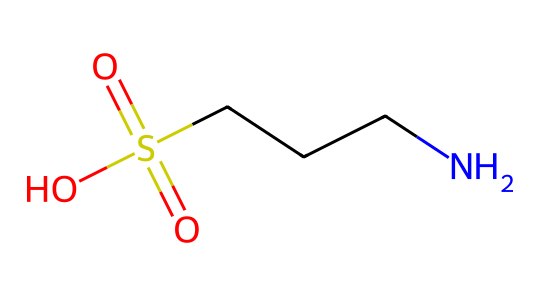What is the molecular formula of taurine? To determine the molecular formula from the SMILES representation, we identify the elements present (C for carbon, N for nitrogen, O for oxygen, and S for sulfur) and count their respective atoms. The SMILES indicates 2 carbon atoms, 1 nitrogen atom, 1 sulfur atom, and 4 oxygen atoms in total, leading to the molecular formula C2H7NO6S.
Answer: C2H7NO6S How many sulfur atoms are in taurine? By analyzing the SMILES representation, we see that there is one sulfur (S) atom represented in the structure, which can be directly counted.
Answer: 1 What functional groups are present in taurine? The SMILES representation shows a sulfonic acid group (indicated by S(=O)(=O)O) and an amine group (CN) attached to the carbon chain. This confirms the presence of a sulfonic acid and an amine functional group in the structure.
Answer: sulfonic acid and amine What kind of compound is taurine primarily classified as? Given that taurine contains an amino group (NH2) and is known as a sulfur-containing amino acid, it is primarily classified as an amino acid. Amino acids are defined by the presence of both amine and carboxylic acid functional groups.
Answer: amino acid What is the oxidation state of the sulfur atom in taurine? In taurine, the sulfur is part of the sulfonic acid group, which typically has a +6 oxidation state. This can be deduced from its bonding where it is double-bonded to two oxygen atoms and single-bonded to a hydroxyl group and an electron-donating atom.
Answer: +6 What aspect of taurine contributes to its solubility in water? The presence of the sulfonic acid group (-SO3H) and the amine group (-NH2) enhances the hydrophilicity of taurine, making the compound polar and thus increasing its solubility in water. This can be inferred from the presence of multiple functional groups that can interact with water.
Answer: sulfonic acid and amine groups 